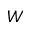<formula> <loc_0><loc_0><loc_500><loc_500>W</formula> 